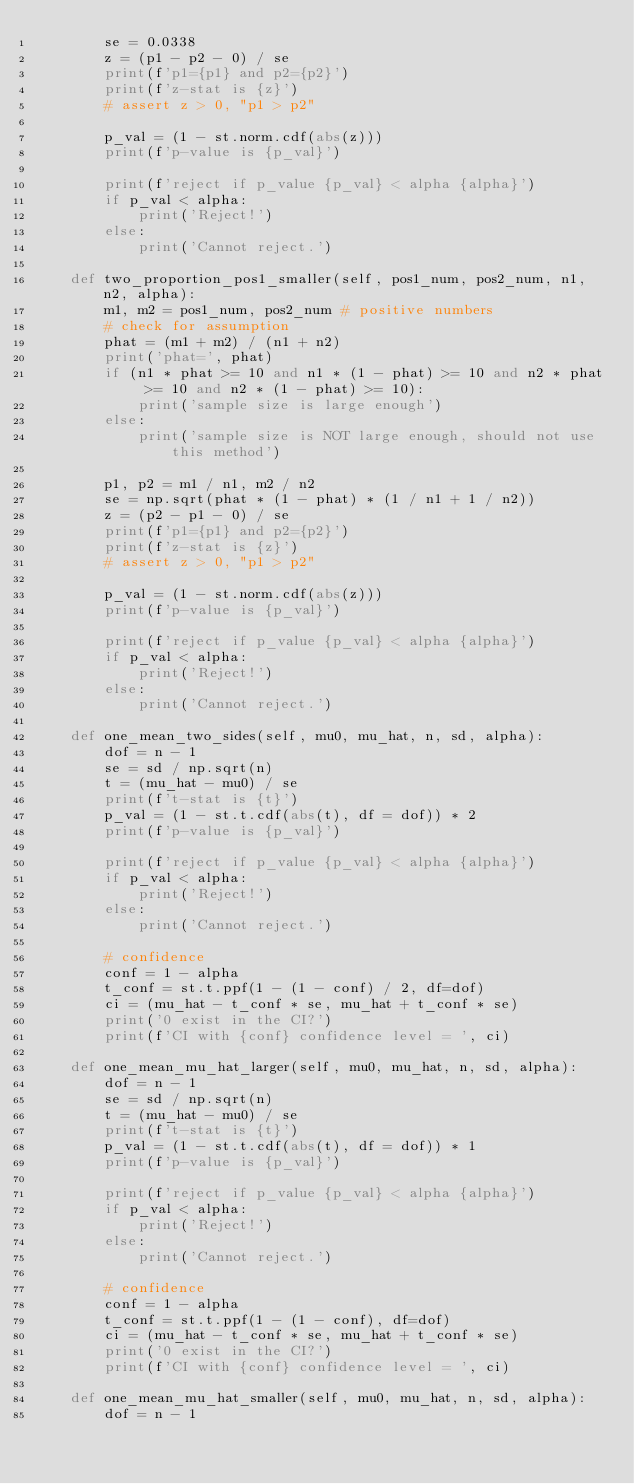<code> <loc_0><loc_0><loc_500><loc_500><_Python_>        se = 0.0338
        z = (p1 - p2 - 0) / se
        print(f'p1={p1} and p2={p2}')
        print(f'z-stat is {z}')
        # assert z > 0, "p1 > p2"

        p_val = (1 - st.norm.cdf(abs(z)))
        print(f'p-value is {p_val}')

        print(f'reject if p_value {p_val} < alpha {alpha}')
        if p_val < alpha:
            print('Reject!')
        else:
            print('Cannot reject.')

    def two_proportion_pos1_smaller(self, pos1_num, pos2_num, n1, n2, alpha):
        m1, m2 = pos1_num, pos2_num # positive numbers
        # check for assumption
        phat = (m1 + m2) / (n1 + n2)
        print('phat=', phat)
        if (n1 * phat >= 10 and n1 * (1 - phat) >= 10 and n2 * phat >= 10 and n2 * (1 - phat) >= 10):
            print('sample size is large enough')
        else:
            print('sample size is NOT large enough, should not use this method')

        p1, p2 = m1 / n1, m2 / n2
        se = np.sqrt(phat * (1 - phat) * (1 / n1 + 1 / n2))
        z = (p2 - p1 - 0) / se
        print(f'p1={p1} and p2={p2}')
        print(f'z-stat is {z}')
        # assert z > 0, "p1 > p2"

        p_val = (1 - st.norm.cdf(abs(z)))
        print(f'p-value is {p_val}')

        print(f'reject if p_value {p_val} < alpha {alpha}')
        if p_val < alpha:
            print('Reject!')
        else:
            print('Cannot reject.')

    def one_mean_two_sides(self, mu0, mu_hat, n, sd, alpha):
        dof = n - 1
        se = sd / np.sqrt(n)
        t = (mu_hat - mu0) / se
        print(f't-stat is {t}')
        p_val = (1 - st.t.cdf(abs(t), df = dof)) * 2
        print(f'p-value is {p_val}')

        print(f'reject if p_value {p_val} < alpha {alpha}')
        if p_val < alpha:
            print('Reject!')
        else:
            print('Cannot reject.')

        # confidence
        conf = 1 - alpha
        t_conf = st.t.ppf(1 - (1 - conf) / 2, df=dof)
        ci = (mu_hat - t_conf * se, mu_hat + t_conf * se)
        print('0 exist in the CI?')
        print(f'CI with {conf} confidence level = ', ci)

    def one_mean_mu_hat_larger(self, mu0, mu_hat, n, sd, alpha):
        dof = n - 1
        se = sd / np.sqrt(n)
        t = (mu_hat - mu0) / se
        print(f't-stat is {t}')
        p_val = (1 - st.t.cdf(abs(t), df = dof)) * 1
        print(f'p-value is {p_val}')

        print(f'reject if p_value {p_val} < alpha {alpha}')
        if p_val < alpha:
            print('Reject!')
        else:
            print('Cannot reject.')

        # confidence
        conf = 1 - alpha
        t_conf = st.t.ppf(1 - (1 - conf), df=dof)
        ci = (mu_hat - t_conf * se, mu_hat + t_conf * se)
        print('0 exist in the CI?')
        print(f'CI with {conf} confidence level = ', ci)

    def one_mean_mu_hat_smaller(self, mu0, mu_hat, n, sd, alpha):
        dof = n - 1</code> 